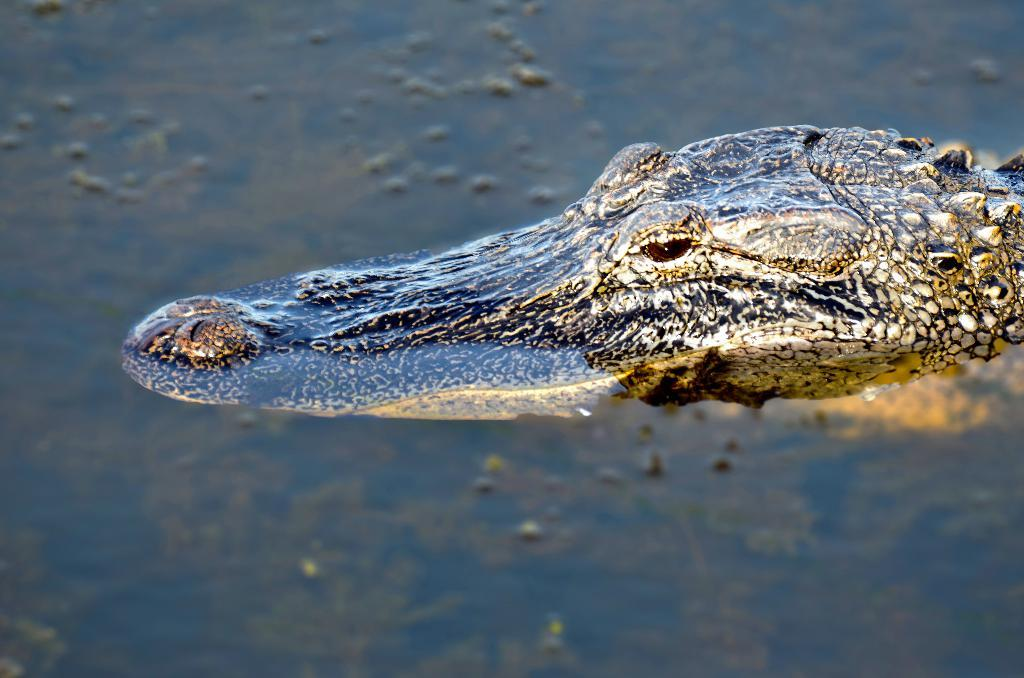What is the primary element visible in the image? There is water in the image. What type of animal can be seen in the image? There is a crocodile in the image. What type of feeling does the crocodile have in the image? The image does not convey any feelings or emotions, so it is not possible to determine the crocodile's feelings. Can you see the crocodile's heart in the image? The image does not show the crocodile's internal organs, so it is not possible to see its heart. 